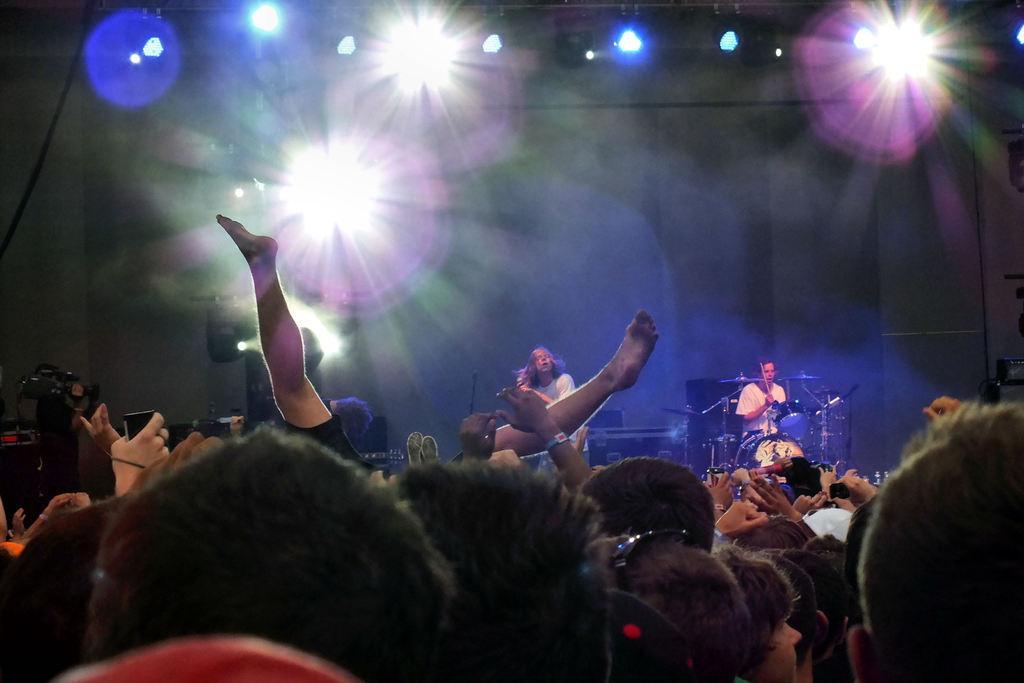Describe this image in one or two sentences. In this image we can see there are two persons playing musical instruments, in front of them there are some audience standing and dancing. In the background there are some colorful lights. 